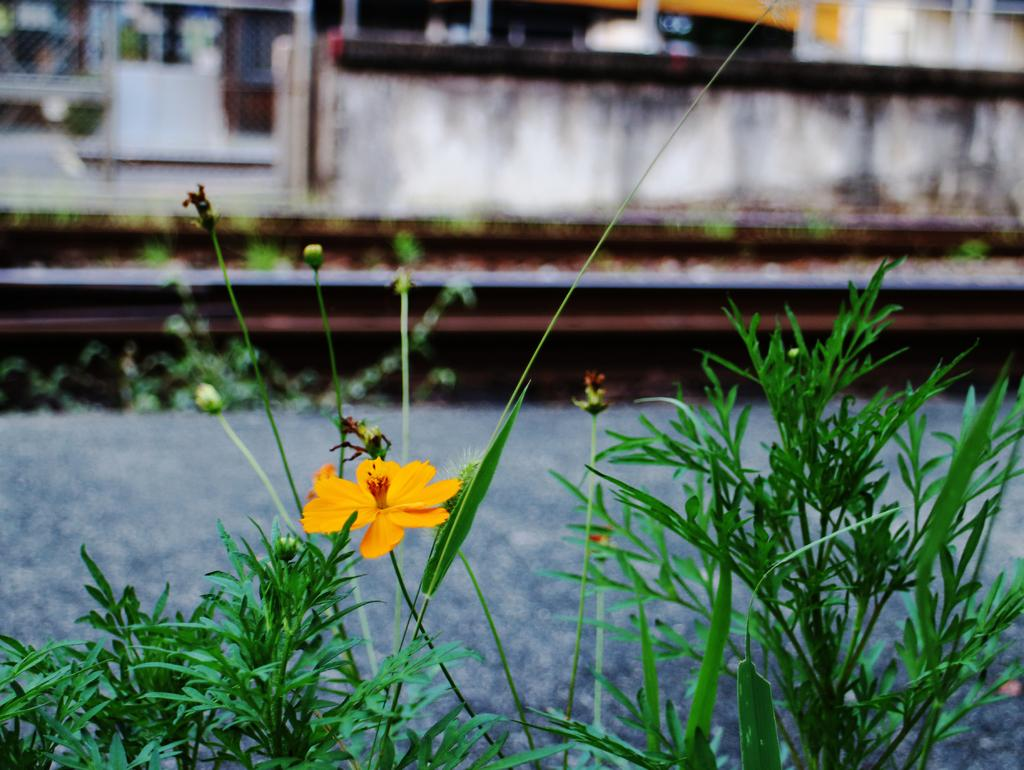What type of living organisms can be seen in the image? There are flowers in a plant in the image. What is visible beside the plant in the image? There is a wall visible beside the plant in the image. What type of view can be seen from the cemetery in the image? There is no cemetery present in the image, so it is not possible to answer that question. 